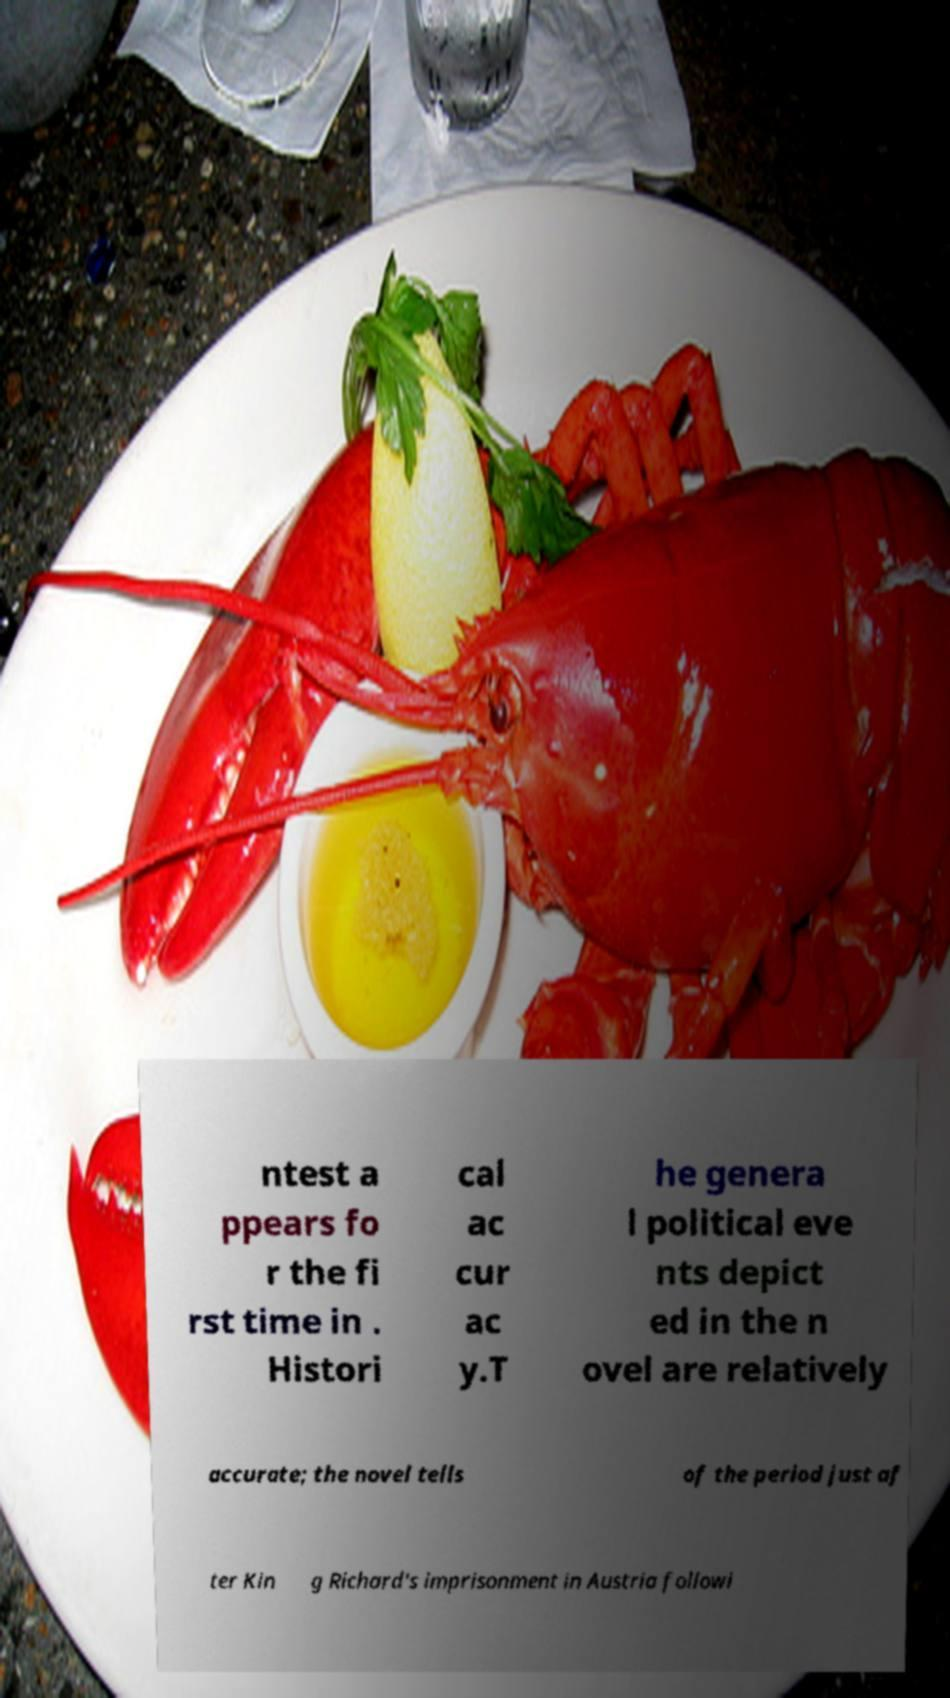There's text embedded in this image that I need extracted. Can you transcribe it verbatim? ntest a ppears fo r the fi rst time in . Histori cal ac cur ac y.T he genera l political eve nts depict ed in the n ovel are relatively accurate; the novel tells of the period just af ter Kin g Richard's imprisonment in Austria followi 